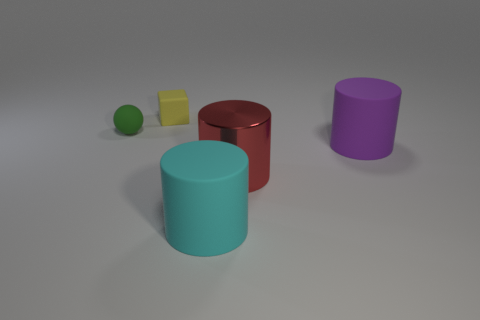How many other objects are the same shape as the small green matte thing?
Give a very brief answer. 0. There is a matte cylinder that is on the right side of the big cyan matte object; is it the same size as the thing behind the ball?
Ensure brevity in your answer.  No. Are there any other yellow things made of the same material as the tiny yellow thing?
Offer a terse response. No. Is there a big cylinder that is behind the small thing left of the thing behind the green rubber object?
Provide a short and direct response. No. Are there any small green balls to the right of the matte block?
Offer a very short reply. No. What number of things are behind the matte thing that is on the right side of the big red object?
Keep it short and to the point. 2. Is the size of the yellow object the same as the rubber object in front of the large purple rubber cylinder?
Your answer should be compact. No. There is a yellow object that is the same material as the big cyan thing; what size is it?
Keep it short and to the point. Small. Is the tiny yellow block made of the same material as the red cylinder?
Provide a succinct answer. No. What is the color of the big matte cylinder that is in front of the big matte cylinder to the right of the rubber cylinder that is left of the red shiny cylinder?
Give a very brief answer. Cyan. 